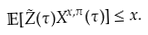<formula> <loc_0><loc_0><loc_500><loc_500>\mathbb { E } [ \tilde { Z } ( \tau ) X ^ { x , \pi } ( \tau ) ] \leq x .</formula> 